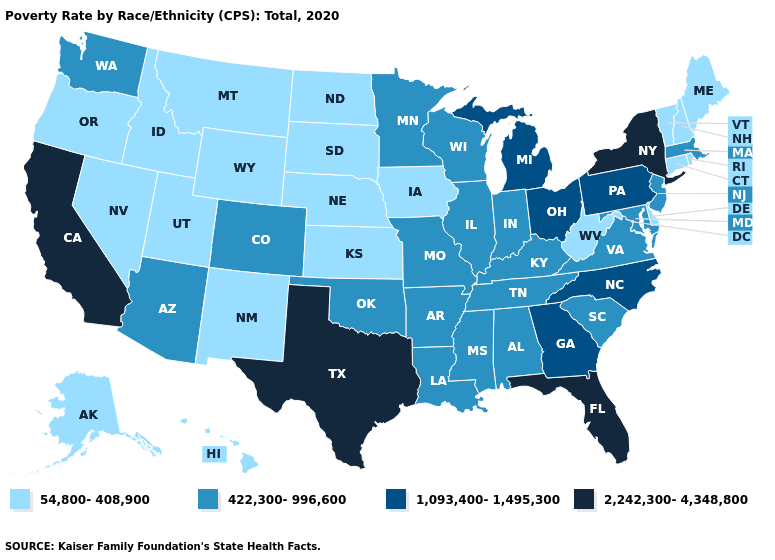Among the states that border New Jersey , does New York have the lowest value?
Be succinct. No. What is the value of Washington?
Concise answer only. 422,300-996,600. Which states hav the highest value in the MidWest?
Answer briefly. Michigan, Ohio. What is the lowest value in states that border Maryland?
Quick response, please. 54,800-408,900. Among the states that border Utah , does Colorado have the lowest value?
Answer briefly. No. Among the states that border New Mexico , which have the lowest value?
Give a very brief answer. Utah. What is the lowest value in states that border Indiana?
Short answer required. 422,300-996,600. What is the value of Vermont?
Concise answer only. 54,800-408,900. What is the value of Illinois?
Be succinct. 422,300-996,600. What is the lowest value in the Northeast?
Quick response, please. 54,800-408,900. Does Iowa have the lowest value in the MidWest?
Be succinct. Yes. Among the states that border New Hampshire , which have the highest value?
Short answer required. Massachusetts. What is the value of Kentucky?
Give a very brief answer. 422,300-996,600. Which states have the highest value in the USA?
Write a very short answer. California, Florida, New York, Texas. Among the states that border Kentucky , does Indiana have the highest value?
Be succinct. No. 